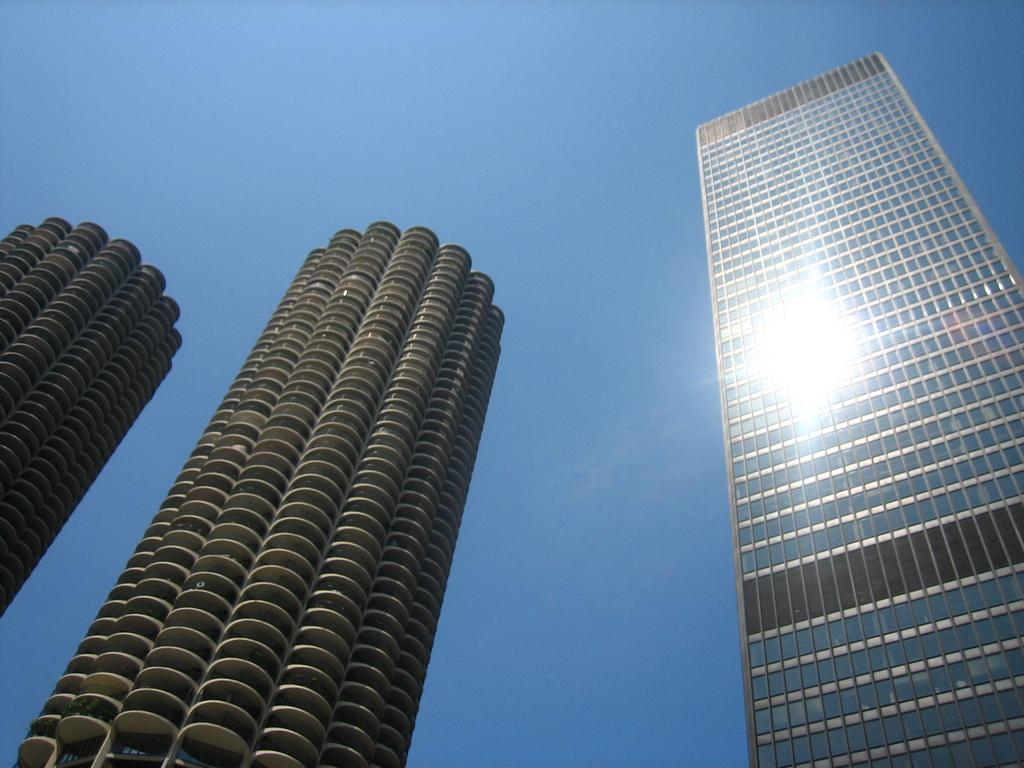What type of structures can be seen in the image? There are buildings in the image. What part of the natural environment is visible in the image? The sky is visible in the background of the image. Is there a hose being used by a stranger near the border in the image? There is no hose, stranger, or border present in the image. 